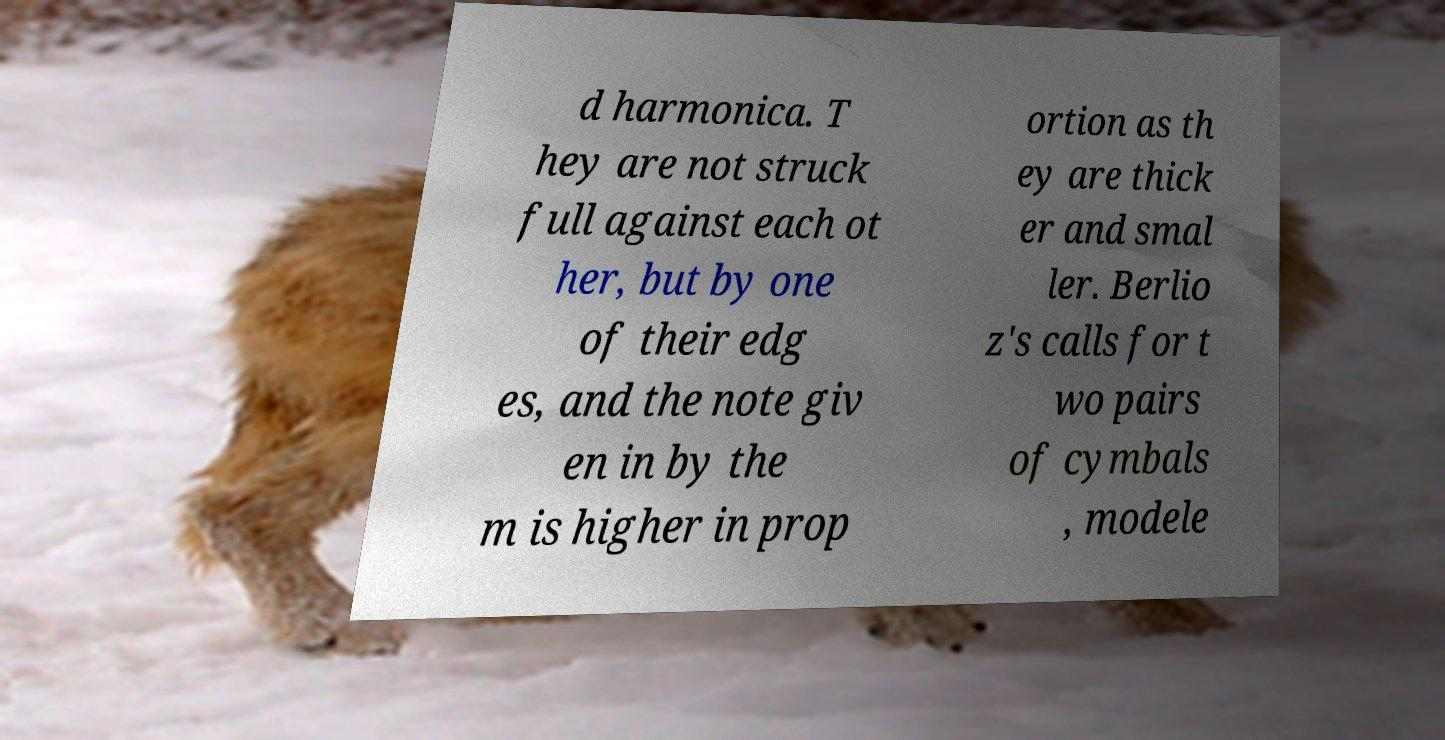Please identify and transcribe the text found in this image. d harmonica. T hey are not struck full against each ot her, but by one of their edg es, and the note giv en in by the m is higher in prop ortion as th ey are thick er and smal ler. Berlio z's calls for t wo pairs of cymbals , modele 